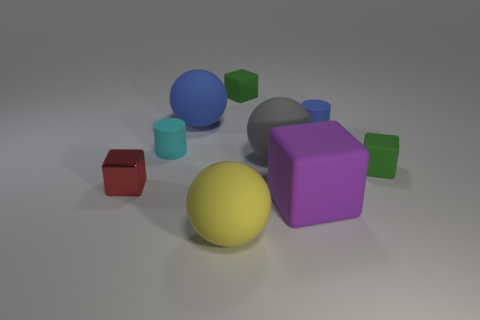What number of purple things are the same shape as the cyan object?
Make the answer very short. 0. What is the material of the block that is to the left of the yellow sphere?
Provide a succinct answer. Metal. There is a green object that is on the left side of the big gray rubber thing; does it have the same shape as the tiny blue thing?
Provide a short and direct response. No. Are there any brown metallic cubes that have the same size as the gray thing?
Your answer should be very brief. No. Do the small blue rubber thing and the blue object left of the large yellow object have the same shape?
Your answer should be compact. No. Are there fewer large gray balls in front of the small blue object than small objects?
Offer a very short reply. Yes. Does the small blue rubber thing have the same shape as the yellow rubber thing?
Provide a succinct answer. No. What size is the purple thing that is the same material as the yellow sphere?
Ensure brevity in your answer.  Large. Are there fewer rubber balls than matte objects?
Your response must be concise. Yes. How many small objects are either metallic cylinders or gray objects?
Provide a short and direct response. 0. 